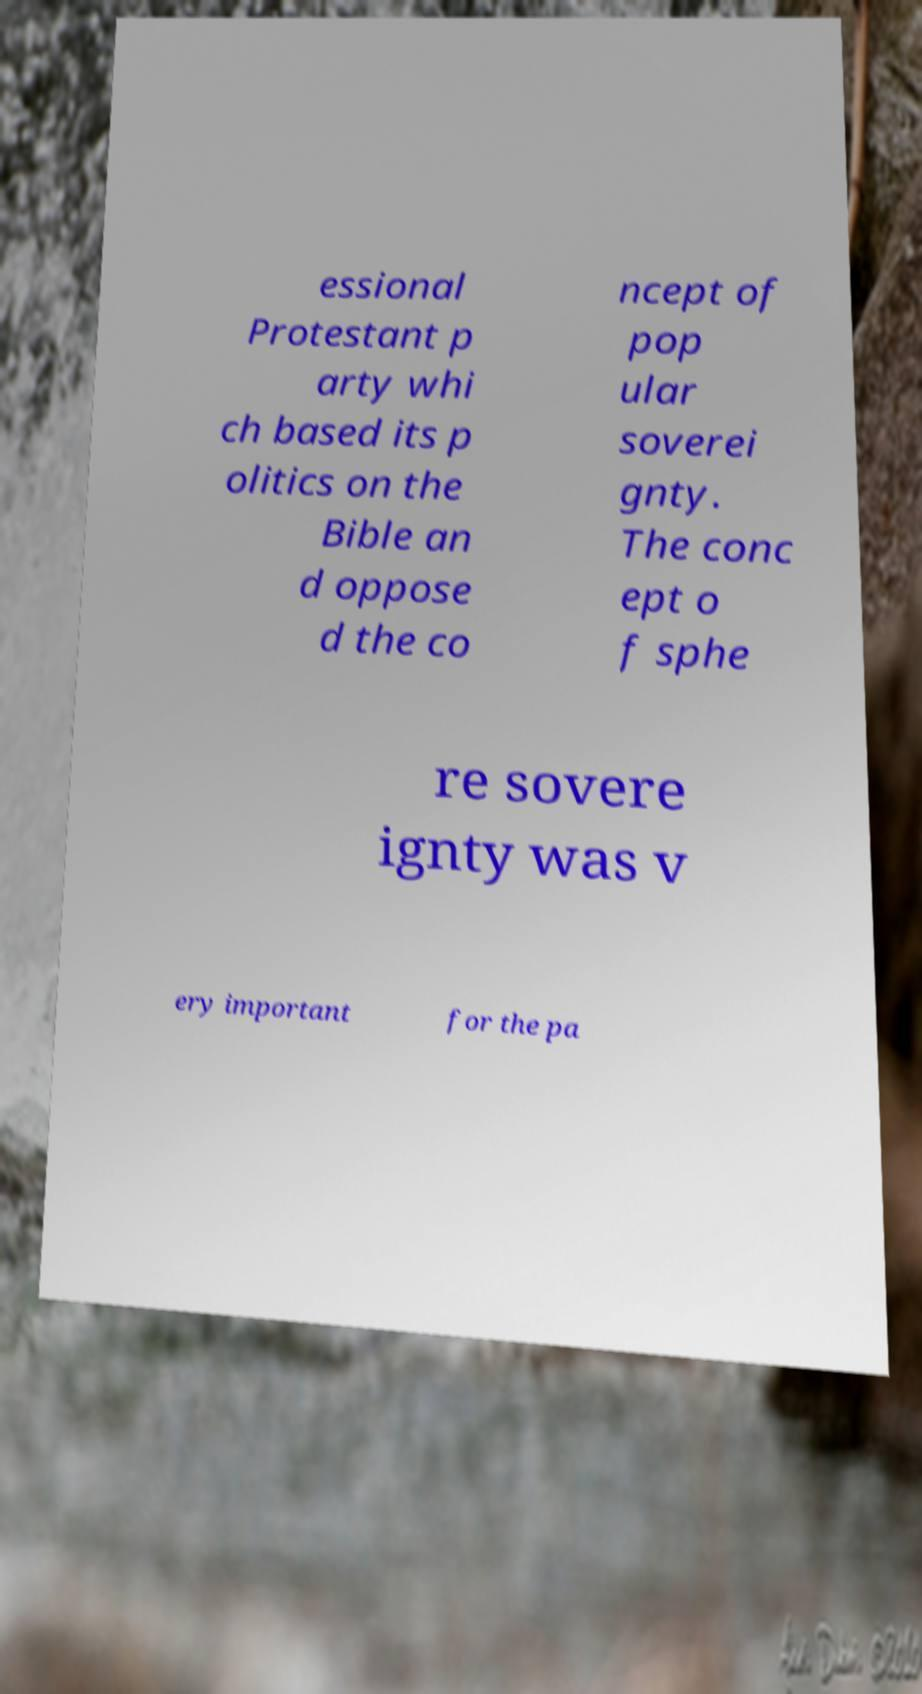Please identify and transcribe the text found in this image. essional Protestant p arty whi ch based its p olitics on the Bible an d oppose d the co ncept of pop ular soverei gnty. The conc ept o f sphe re sovere ignty was v ery important for the pa 